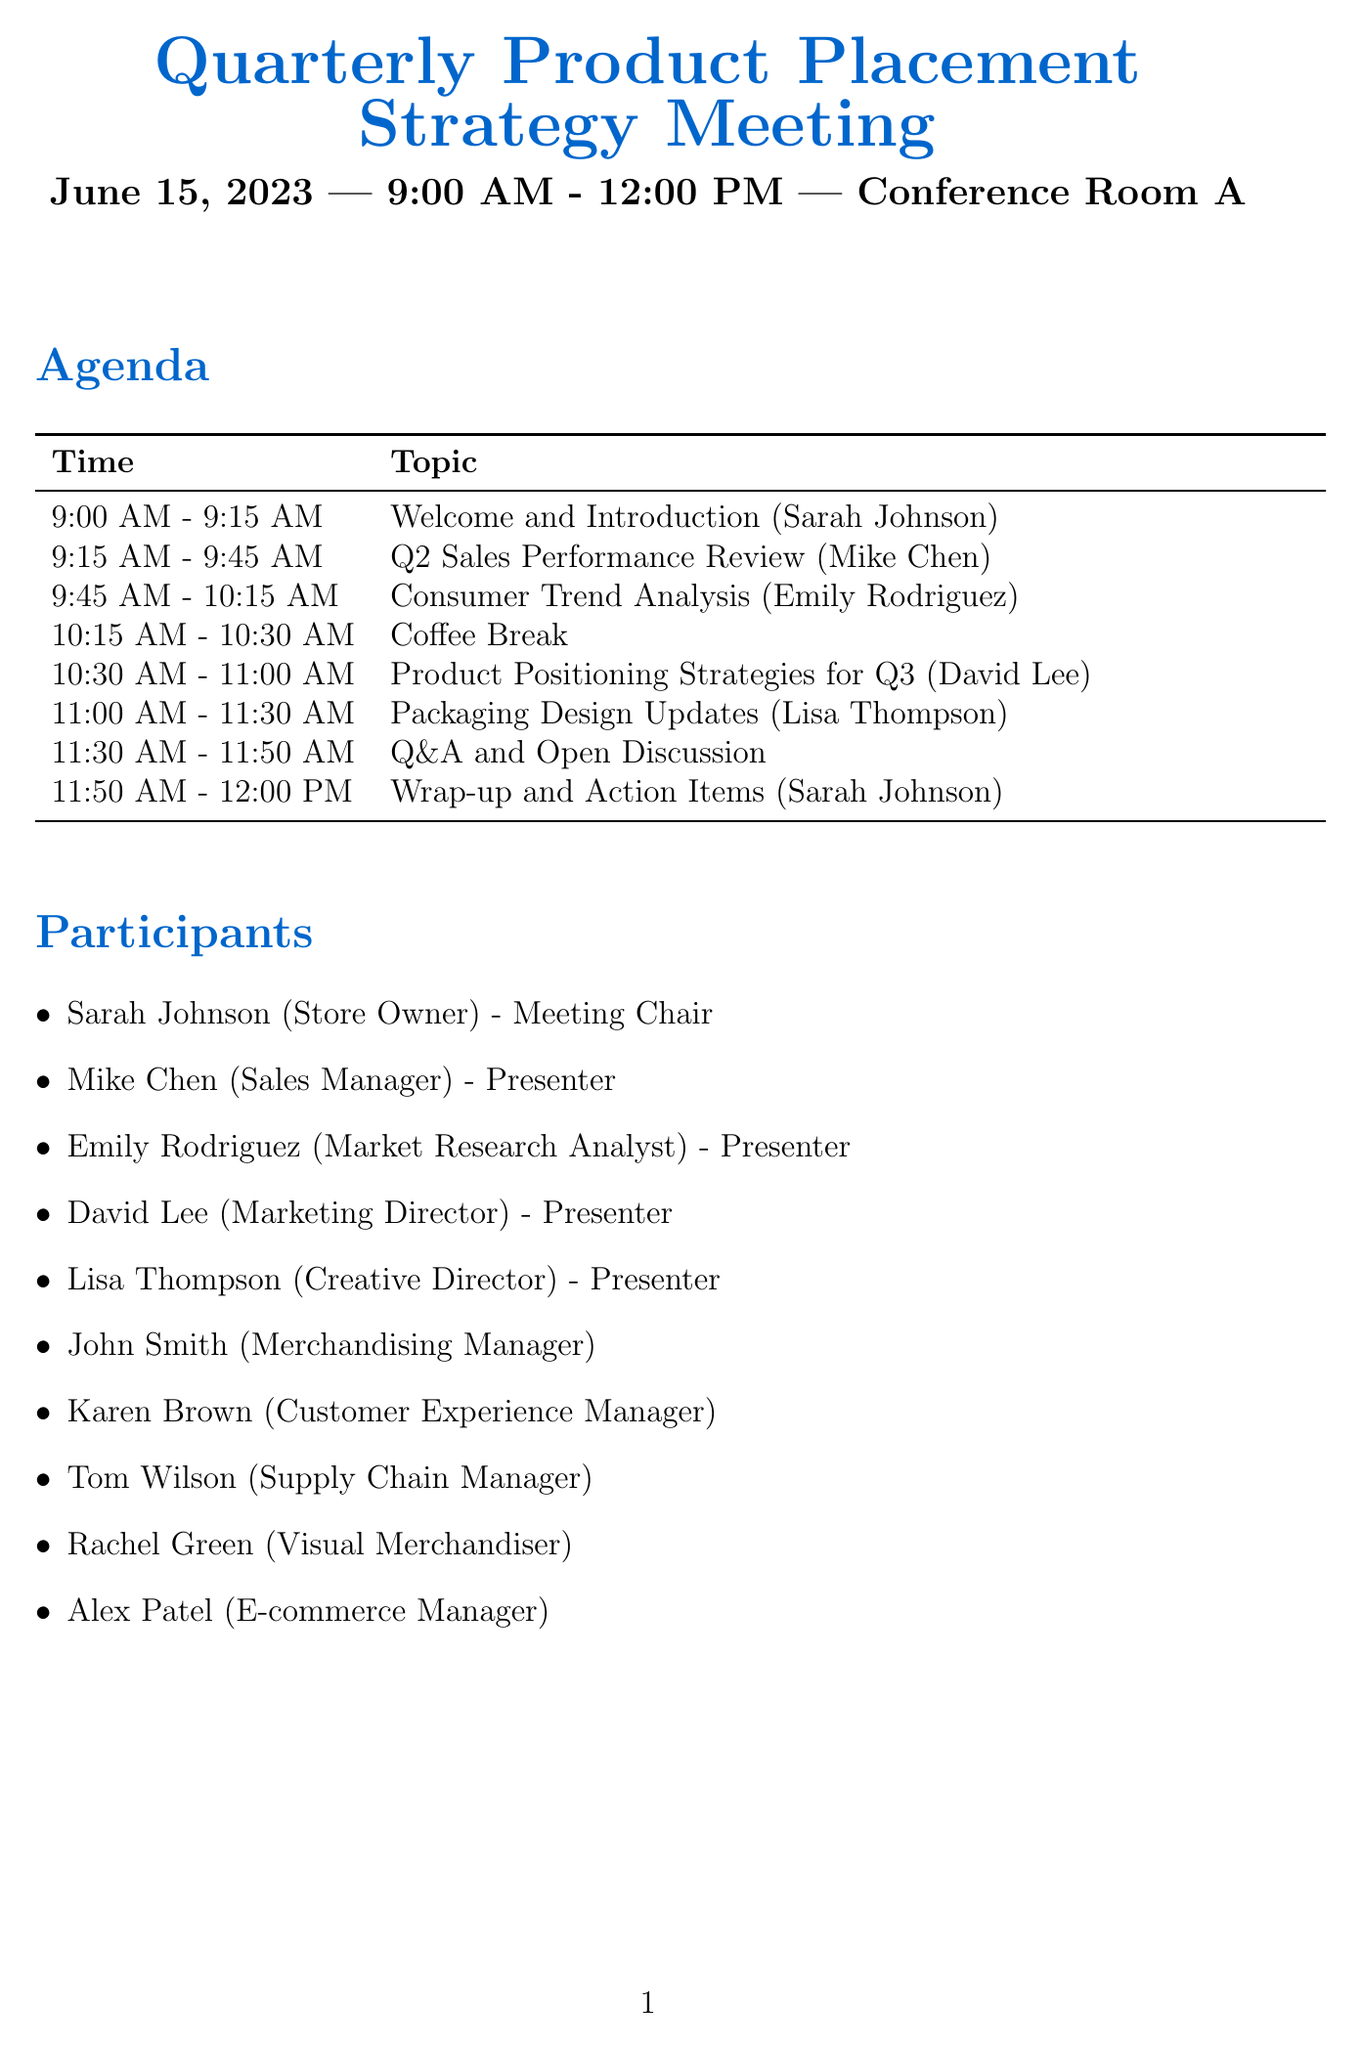What is the date of the meeting? The date of the meeting is mentioned explicitly in the document under the meeting details.
Answer: June 15, 2023 Who will present the Q2 Sales Performance Review? The document specifies presenters next to each agenda item, including who will present the Q2 Sales Performance Review.
Answer: Mike Chen What time is the Coffee Break scheduled? The time for the Coffee Break is clearly listed in the agenda section of the document.
Answer: 10:15 AM - 10:30 AM How many participants are attending the meeting? The total number of participants can be counted from the participant list provided in the document.
Answer: Ten Which topic is presented by Lisa Thompson? The document lists presenters alongside their respective topics, allowing us to identify which topic Lisa Thompson will cover.
Answer: Packaging Design Updates What key discussion point mentions competitor analysis? The key discussion points are outlined in a list format in the document, and one of them addresses competitor analysis explicitly.
Answer: Competitor analysis and differentiation strategies Who is the Meeting Chair? The document identifies the roles of participants, including who is designated as the Meeting Chair.
Answer: Sarah Johnson What is one of the required materials for this meeting? The document lists all required materials to prepare for the meeting, indicating what is needed.
Answer: Q2 Sales Report 